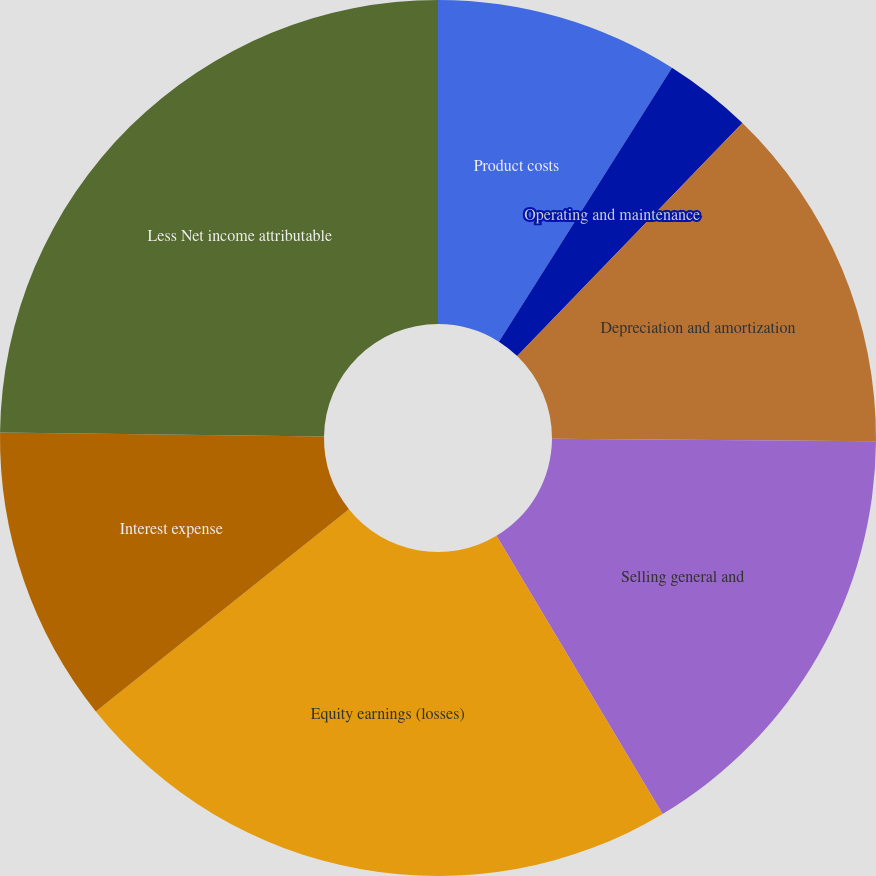Convert chart. <chart><loc_0><loc_0><loc_500><loc_500><pie_chart><fcel>Product costs<fcel>Operating and maintenance<fcel>Depreciation and amortization<fcel>Selling general and<fcel>Equity earnings (losses)<fcel>Interest expense<fcel>Less Net income attributable<nl><fcel>8.97%<fcel>3.26%<fcel>12.89%<fcel>16.31%<fcel>22.84%<fcel>10.93%<fcel>24.8%<nl></chart> 